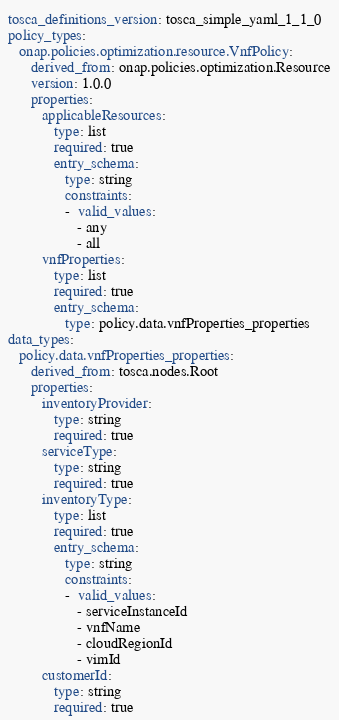Convert code to text. <code><loc_0><loc_0><loc_500><loc_500><_YAML_>tosca_definitions_version: tosca_simple_yaml_1_1_0
policy_types:
   onap.policies.optimization.resource.VnfPolicy:
      derived_from: onap.policies.optimization.Resource
      version: 1.0.0
      properties:
         applicableResources:
            type: list
            required: true
            entry_schema:
               type: string
               constraints:
               -  valid_values:
                  - any
                  - all
         vnfProperties:
            type: list
            required: true
            entry_schema:
               type: policy.data.vnfProperties_properties
data_types:
   policy.data.vnfProperties_properties:
      derived_from: tosca.nodes.Root
      properties:
         inventoryProvider:
            type: string
            required: true
         serviceType:
            type: string
            required: true
         inventoryType:
            type: list
            required: true
            entry_schema:
               type: string
               constraints:
               -  valid_values:
                  - serviceInstanceId
                  - vnfName
                  - cloudRegionId
                  - vimId
         customerId:
            type: string
            required: true</code> 